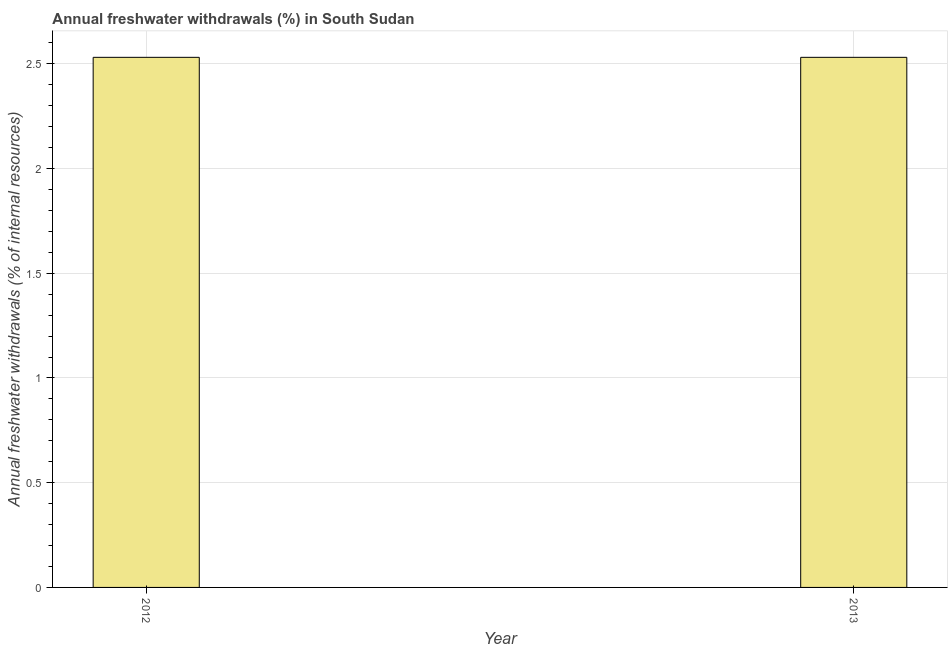Does the graph contain grids?
Offer a very short reply. Yes. What is the title of the graph?
Make the answer very short. Annual freshwater withdrawals (%) in South Sudan. What is the label or title of the X-axis?
Offer a terse response. Year. What is the label or title of the Y-axis?
Give a very brief answer. Annual freshwater withdrawals (% of internal resources). What is the annual freshwater withdrawals in 2013?
Make the answer very short. 2.53. Across all years, what is the maximum annual freshwater withdrawals?
Offer a very short reply. 2.53. Across all years, what is the minimum annual freshwater withdrawals?
Your answer should be very brief. 2.53. In which year was the annual freshwater withdrawals maximum?
Make the answer very short. 2012. What is the sum of the annual freshwater withdrawals?
Offer a terse response. 5.06. What is the difference between the annual freshwater withdrawals in 2012 and 2013?
Your answer should be compact. 0. What is the average annual freshwater withdrawals per year?
Keep it short and to the point. 2.53. What is the median annual freshwater withdrawals?
Offer a terse response. 2.53. Do a majority of the years between 2013 and 2012 (inclusive) have annual freshwater withdrawals greater than 0.2 %?
Your response must be concise. No. What is the ratio of the annual freshwater withdrawals in 2012 to that in 2013?
Ensure brevity in your answer.  1. Is the annual freshwater withdrawals in 2012 less than that in 2013?
Make the answer very short. No. In how many years, is the annual freshwater withdrawals greater than the average annual freshwater withdrawals taken over all years?
Your response must be concise. 0. How many bars are there?
Make the answer very short. 2. Are all the bars in the graph horizontal?
Your answer should be compact. No. What is the difference between two consecutive major ticks on the Y-axis?
Your answer should be compact. 0.5. Are the values on the major ticks of Y-axis written in scientific E-notation?
Your response must be concise. No. What is the Annual freshwater withdrawals (% of internal resources) of 2012?
Provide a succinct answer. 2.53. What is the Annual freshwater withdrawals (% of internal resources) of 2013?
Make the answer very short. 2.53. What is the difference between the Annual freshwater withdrawals (% of internal resources) in 2012 and 2013?
Keep it short and to the point. 0. What is the ratio of the Annual freshwater withdrawals (% of internal resources) in 2012 to that in 2013?
Keep it short and to the point. 1. 